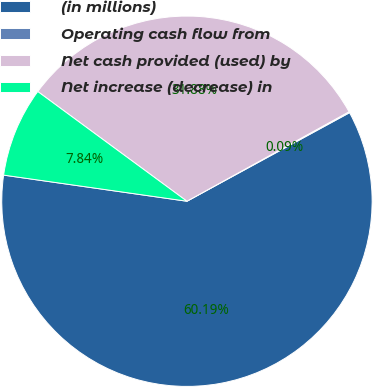Convert chart to OTSL. <chart><loc_0><loc_0><loc_500><loc_500><pie_chart><fcel>(in millions)<fcel>Operating cash flow from<fcel>Net cash provided (used) by<fcel>Net increase (decrease) in<nl><fcel>60.19%<fcel>0.09%<fcel>31.88%<fcel>7.84%<nl></chart> 